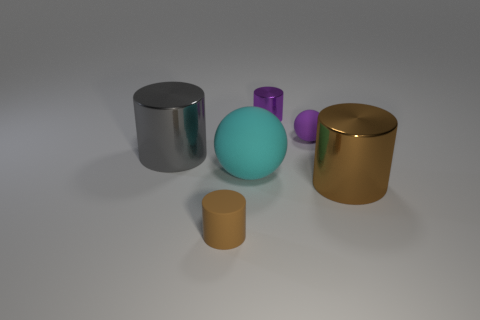What number of metallic objects are either big gray cylinders or cyan balls?
Make the answer very short. 1. Is there a big brown metallic object that is behind the large metallic cylinder on the left side of the tiny cylinder that is behind the large brown shiny cylinder?
Your answer should be compact. No. There is a small purple metal cylinder; how many matte things are left of it?
Your answer should be compact. 2. There is a ball that is the same color as the tiny metal cylinder; what is its material?
Keep it short and to the point. Rubber. What number of small objects are either spheres or metallic cylinders?
Your answer should be compact. 2. There is a small matte object that is in front of the purple matte ball; what is its shape?
Offer a terse response. Cylinder. Is there a matte sphere that has the same color as the tiny rubber cylinder?
Your answer should be compact. No. There is a shiny cylinder that is in front of the big cyan rubber sphere; is it the same size as the cylinder that is behind the large gray thing?
Offer a very short reply. No. Is the number of purple matte things on the left side of the tiny matte ball greater than the number of tiny brown cylinders that are to the right of the brown matte cylinder?
Offer a terse response. No. Are there any large red things made of the same material as the tiny brown object?
Give a very brief answer. No. 